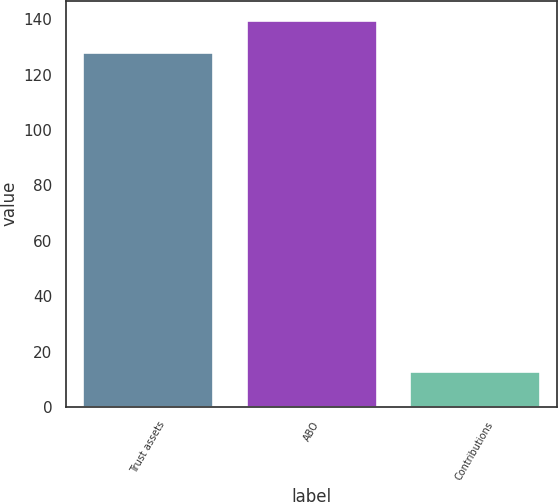<chart> <loc_0><loc_0><loc_500><loc_500><bar_chart><fcel>Trust assets<fcel>ABO<fcel>Contributions<nl><fcel>128<fcel>139.7<fcel>13<nl></chart> 